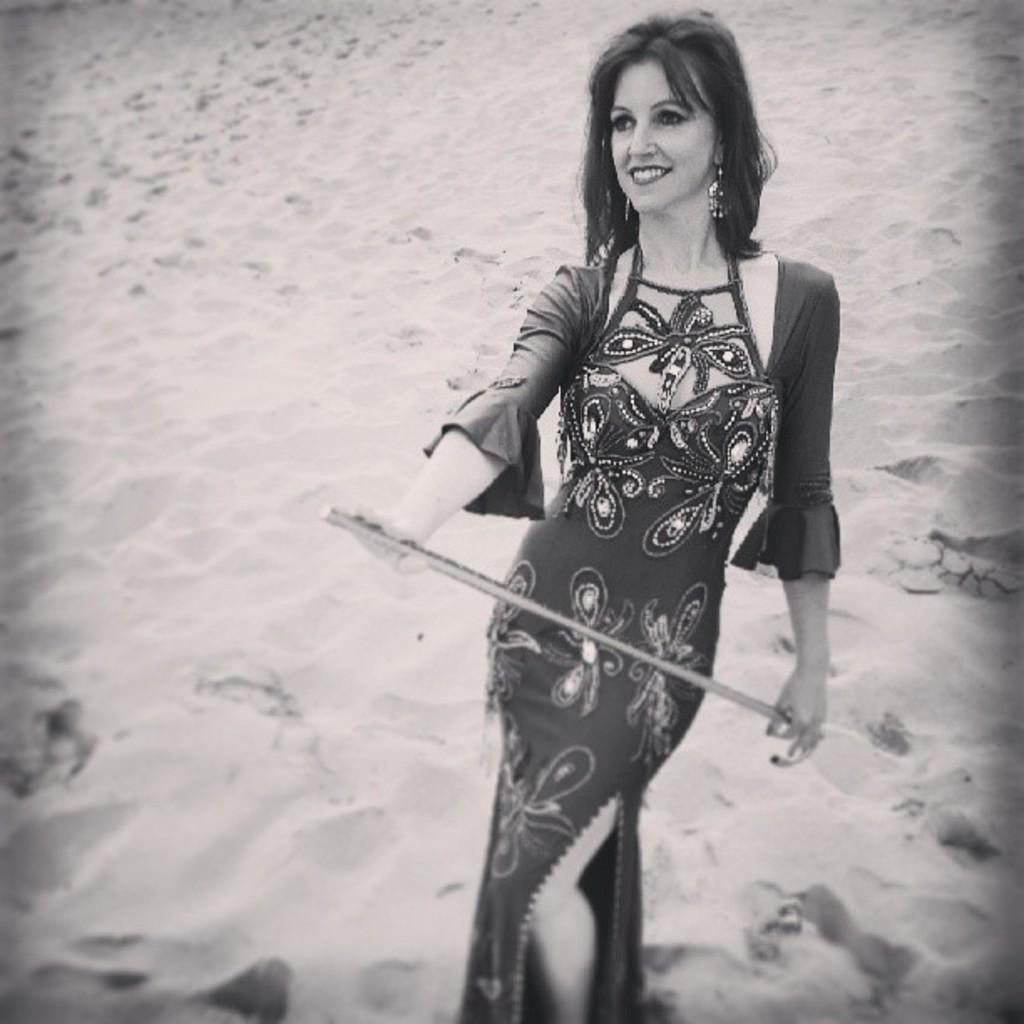What is the color scheme of the image? The image is black and white. Who is present in the image? There is a woman in the image. What is the woman holding in the image? The woman is holding an object. What is the woman's facial expression in the image? The woman is smiling. What type of environment is visible in the background of the image? There is sand visible in the background of the image. How many bikes are present in the image? There are no bikes present in the image. What fact can be learned about the woman's favorite color from the image? The image is black and white, so it does not provide any information about the woman's favorite color. 